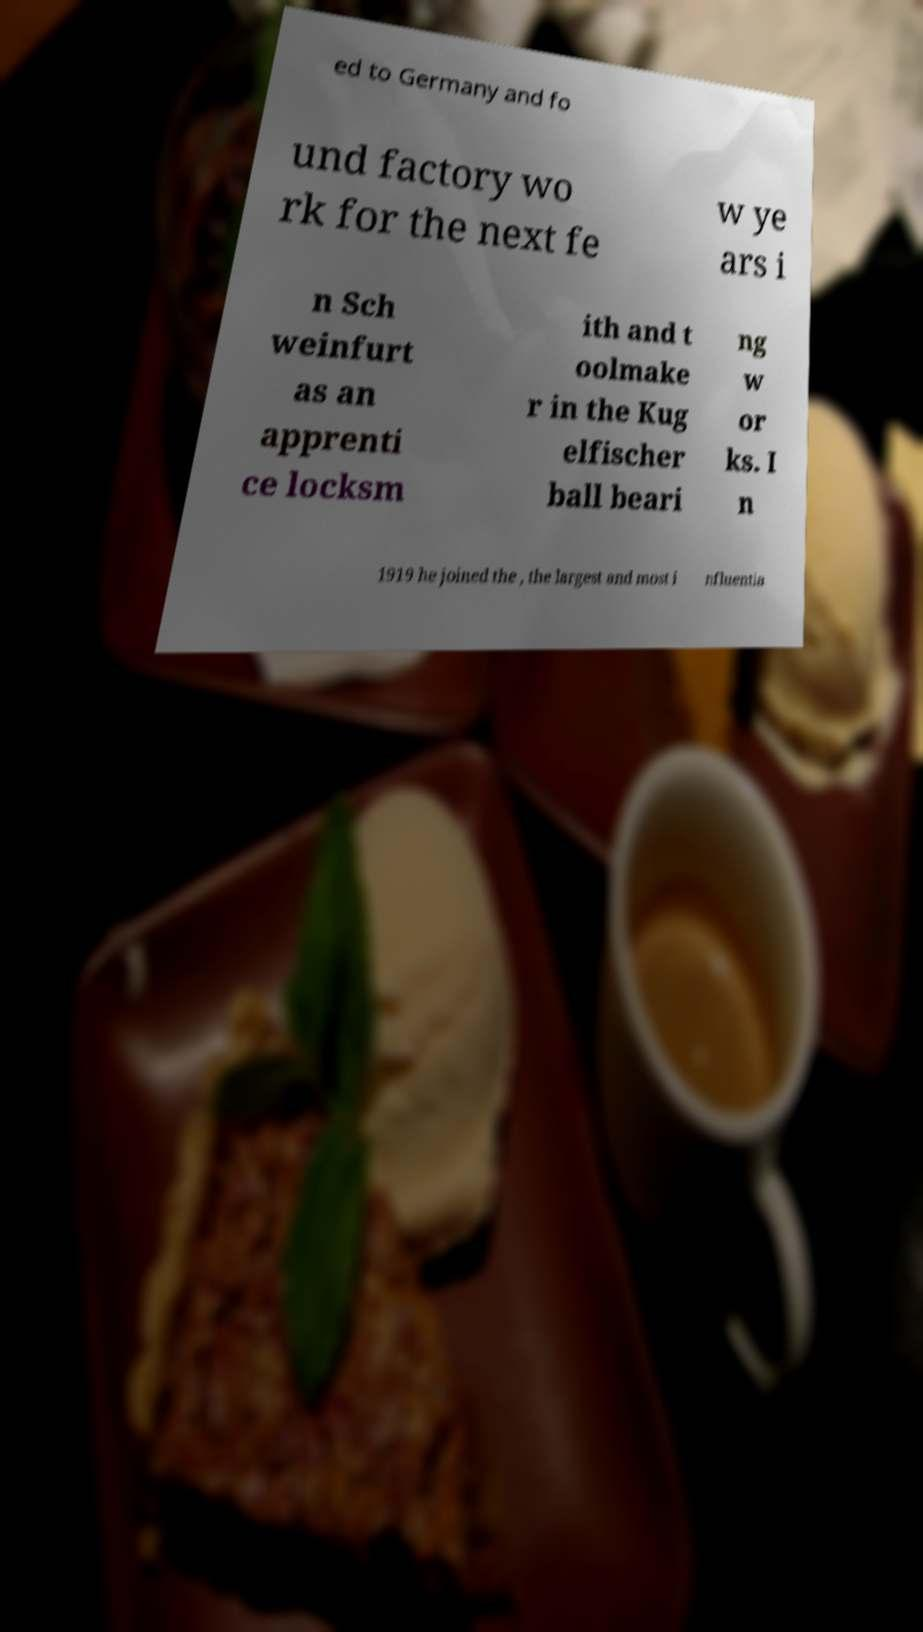Could you assist in decoding the text presented in this image and type it out clearly? ed to Germany and fo und factory wo rk for the next fe w ye ars i n Sch weinfurt as an apprenti ce locksm ith and t oolmake r in the Kug elfischer ball beari ng w or ks. I n 1919 he joined the , the largest and most i nfluentia 